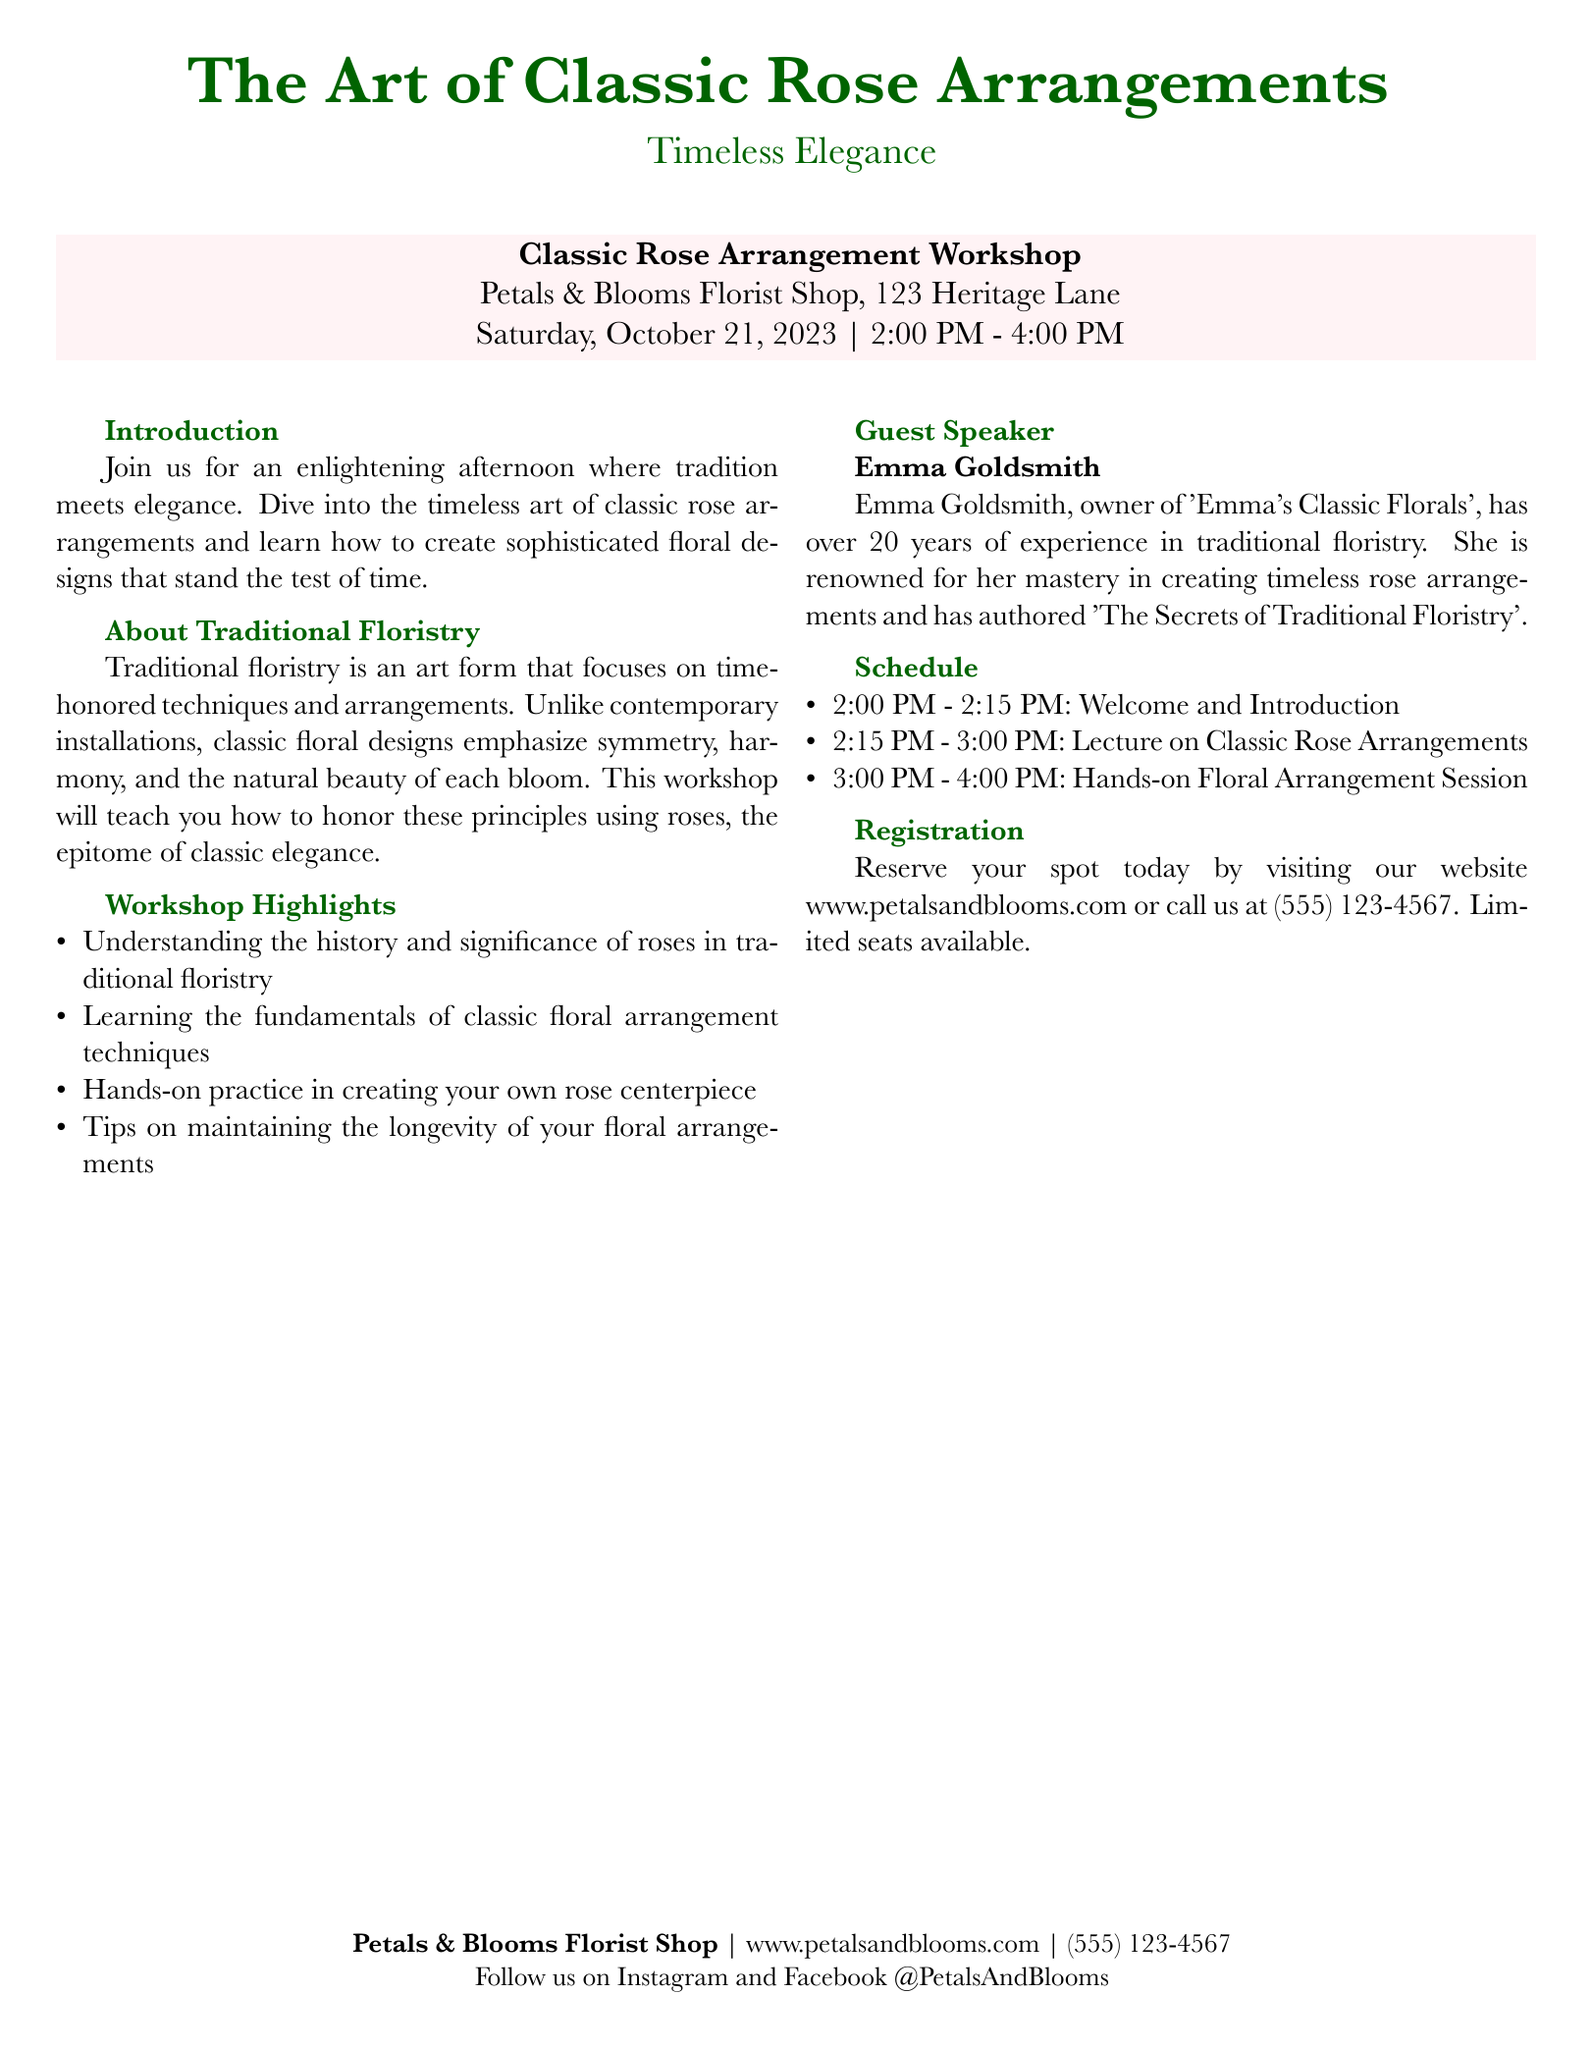What is the title of the workshop? The title of the workshop is found at the top of the document and specifies the focus of the event.
Answer: The Art of Classic Rose Arrangements Who is the guest speaker? The document provides the name of the guest speaker, a key figure in the workshop.
Answer: Emma Goldsmith How many years of experience does the guest speaker have? The document mentions the guest speaker's experience in traditional floristry, important for credibility.
Answer: over 20 years What are attendees expected to create during the workshop? The workshop highlights a specific activity, which is central to its purpose.
Answer: rose centerpiece What is the website for registration? The document includes the website where interested individuals can register, which is vital for accessibility.
Answer: www.petalsandblooms.com What time does the lecture on classic rose arrangements start? The schedule section of the document specifies the start time for a key part of the workshop.
Answer: 2:15 PM What color is used for the workshop highlight box? The visual design elements of the document include color choices, providing context for its aesthetic appeal.
Answer: rosepink What can participants learn about maintaining arrangements? The workshop highlights include a specific topic on floral arrangements, indicating its educational value.
Answer: longevity of your floral arrangements 